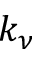Convert formula to latex. <formula><loc_0><loc_0><loc_500><loc_500>k _ { \nu }</formula> 